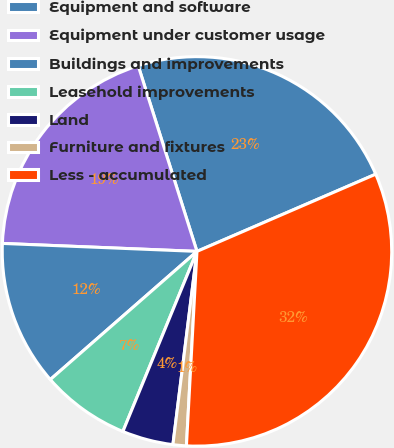Convert chart to OTSL. <chart><loc_0><loc_0><loc_500><loc_500><pie_chart><fcel>Equipment and software<fcel>Equipment under customer usage<fcel>Buildings and improvements<fcel>Leasehold improvements<fcel>Land<fcel>Furniture and fixtures<fcel>Less - accumulated<nl><fcel>23.39%<fcel>19.47%<fcel>12.08%<fcel>7.36%<fcel>4.24%<fcel>1.11%<fcel>32.35%<nl></chart> 